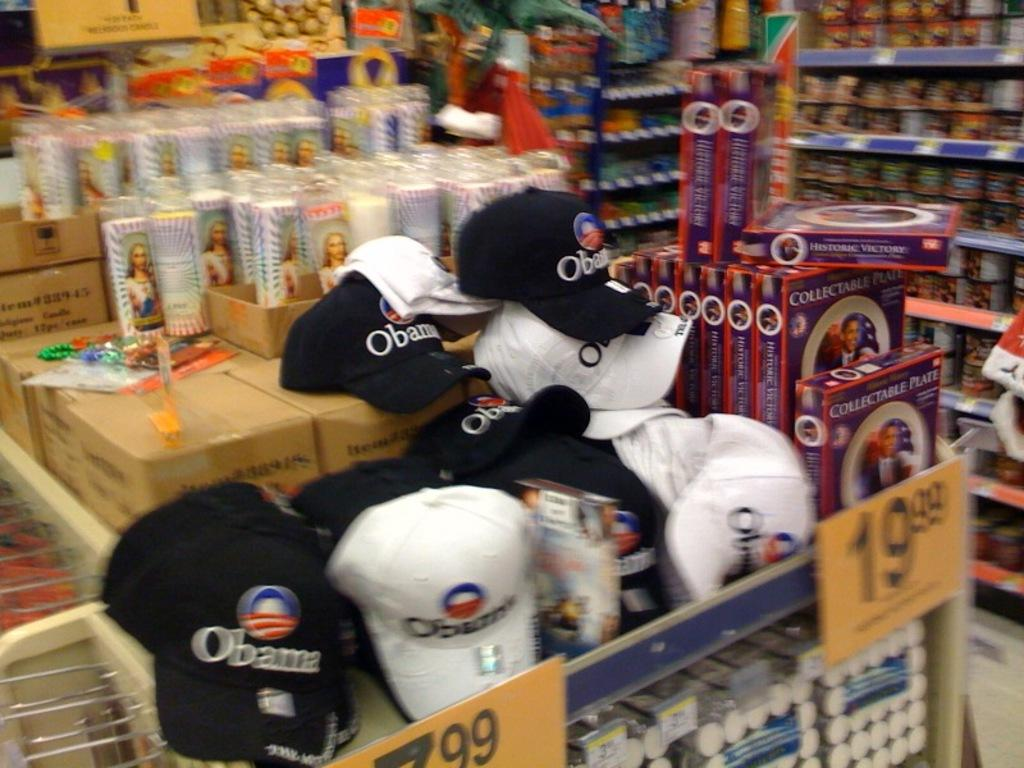<image>
Write a terse but informative summary of the picture. A display stand that shows Obama hats in black and white 